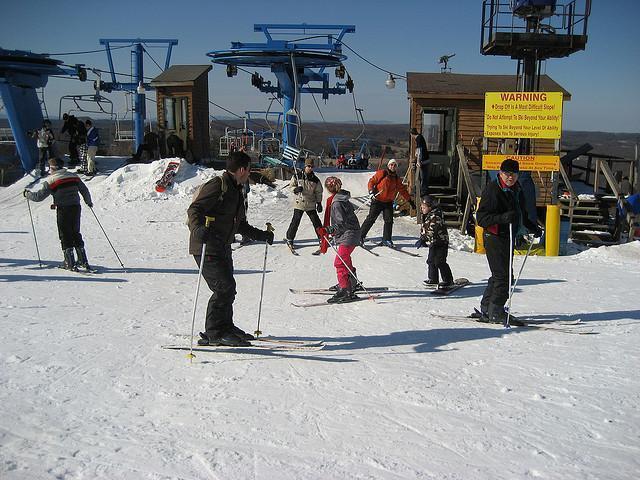How many people are standing?
Give a very brief answer. 7. How many people are there?
Give a very brief answer. 4. 